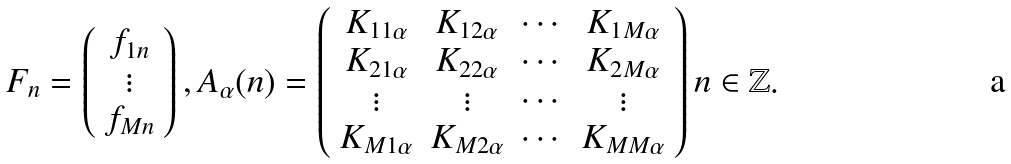<formula> <loc_0><loc_0><loc_500><loc_500>F _ { n } = \left ( \begin{array} { c } f _ { 1 n } \\ \vdots \\ f _ { M n } \\ \end{array} \right ) , A _ { \alpha } ( n ) = \left ( \begin{array} { c c c c } K _ { 1 1 \alpha } & K _ { 1 2 \alpha } & \cdots & K _ { 1 M \alpha } \\ K _ { 2 1 \alpha } & K _ { 2 2 \alpha } & \cdots & K _ { 2 M \alpha } \\ \vdots & \vdots & \cdots & \vdots \\ K _ { M 1 \alpha } & K _ { M 2 \alpha } & \cdots & K _ { M M \alpha } \\ \end{array} \right ) n \in \mathbb { Z } .</formula> 